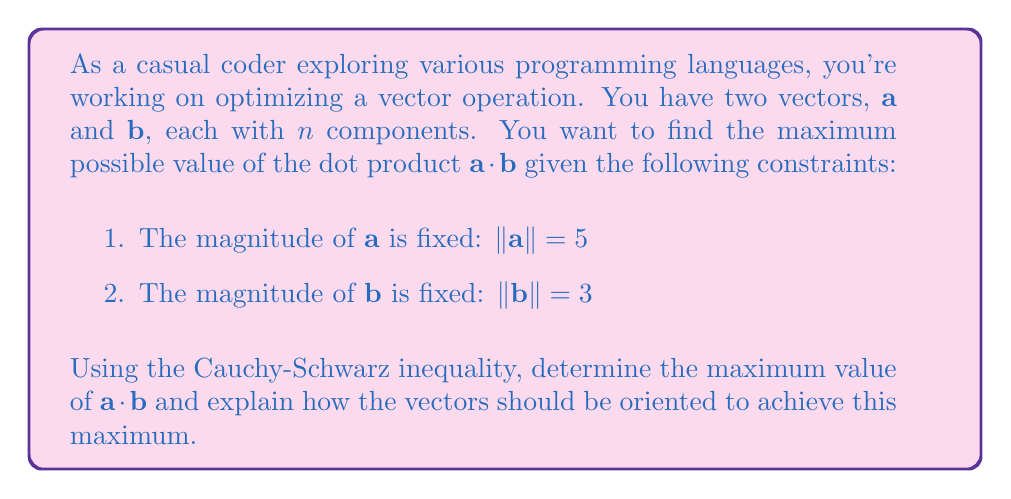Show me your answer to this math problem. Let's approach this step-by-step using the Cauchy-Schwarz inequality:

1) The Cauchy-Schwarz inequality states that for any two vectors $\mathbf{u}$ and $\mathbf{v}$:

   $$|\mathbf{u} \cdot \mathbf{v}| \leq \|\mathbf{u}\| \|\mathbf{v}\|$$

   with equality if and only if one vector is a scalar multiple of the other.

2) In our case, $\mathbf{u} = \mathbf{a}$ and $\mathbf{v} = \mathbf{b}$. We're given that:

   $$\|\mathbf{a}\| = 5 \text{ and } \|\mathbf{b}\| = 3$$

3) Applying the Cauchy-Schwarz inequality:

   $$|\mathbf{a} \cdot \mathbf{b}| \leq \|\mathbf{a}\| \|\mathbf{b}\| = 5 \cdot 3 = 15$$

4) This means that the maximum absolute value of the dot product is 15. Since we're asked for the maximum value (not absolute value), this will be positive 15.

5) To achieve this maximum, the vectors must be scalar multiples of each other. Given their magnitudes, we can conclude that:

   $$\mathbf{b} = \frac{3}{5}\mathbf{a}$$

   This means the vectors must point in the same direction to maximize their dot product.

In programming terms, this optimization suggests that when performing operations involving dot products, aligning the vectors in the same direction will yield the maximum result, given fixed magnitudes.
Answer: The maximum value of $\mathbf{a} \cdot \mathbf{b}$ is 15. To achieve this, vectors $\mathbf{a}$ and $\mathbf{b}$ must be parallel and point in the same direction, with $\mathbf{b} = \frac{3}{5}\mathbf{a}$. 